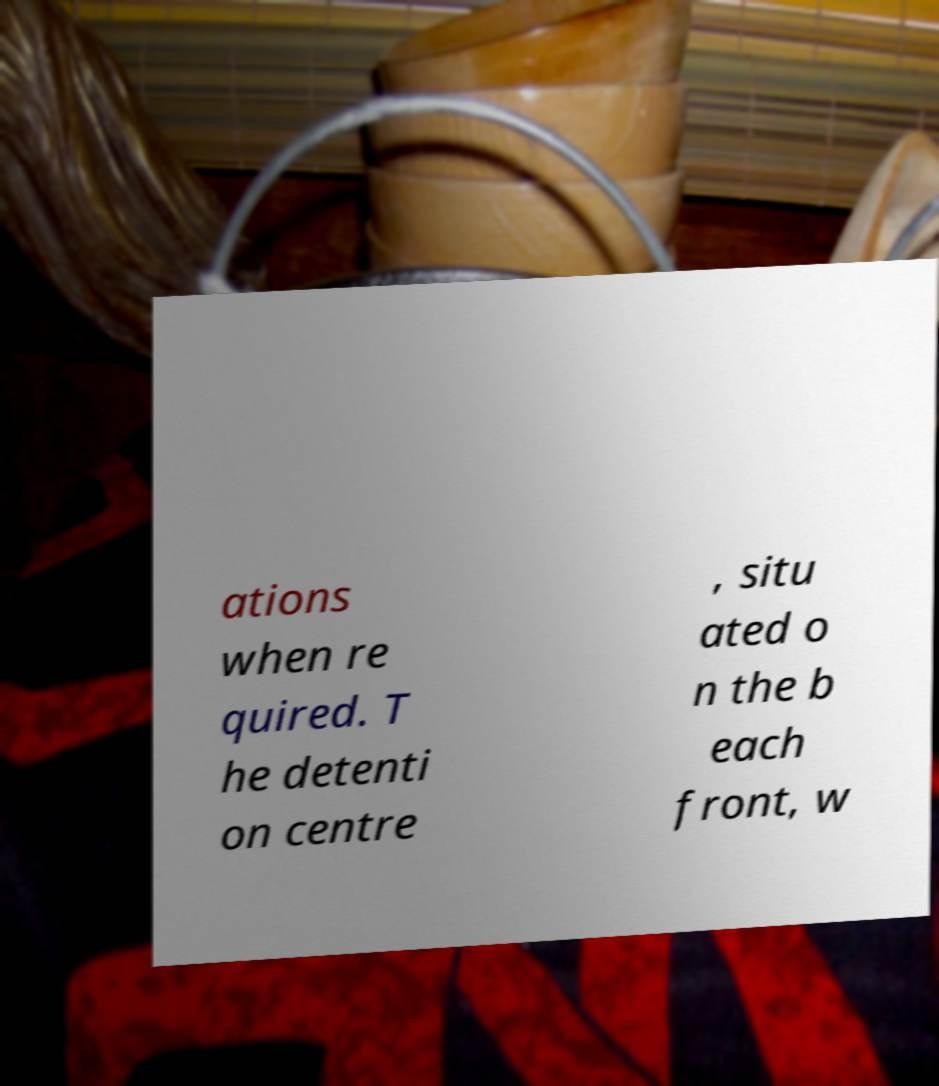Could you extract and type out the text from this image? ations when re quired. T he detenti on centre , situ ated o n the b each front, w 